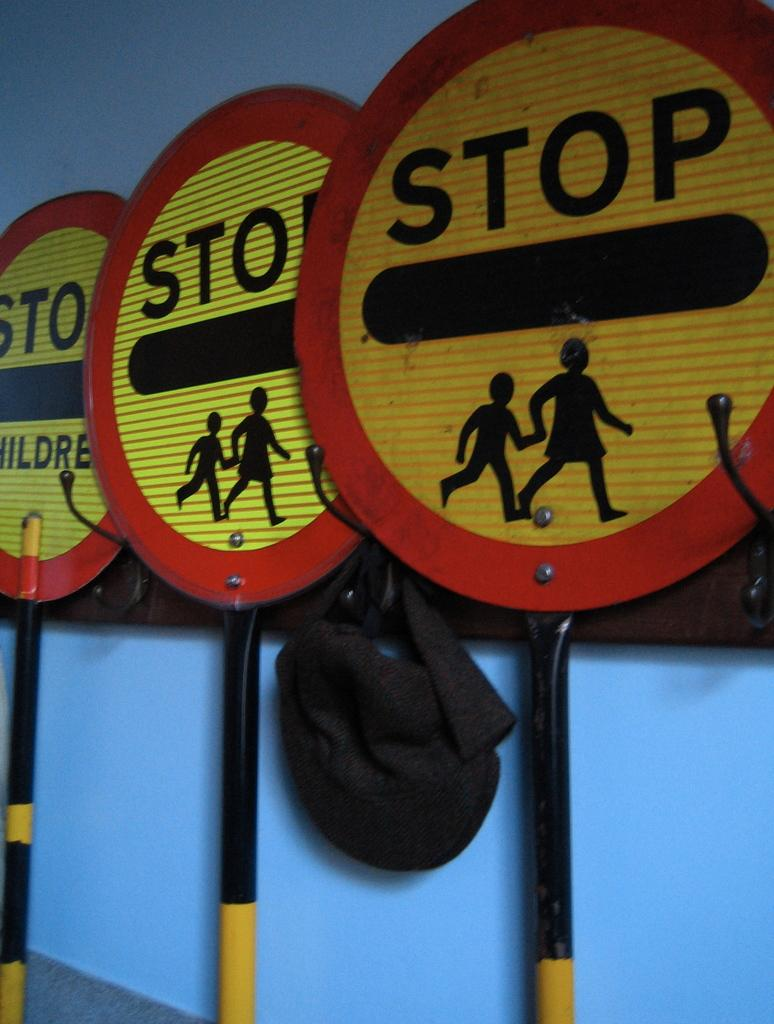<image>
Write a terse but informative summary of the picture. THREE ROUND STOP SIGNS WITH FIGURES OF CHILDREN 